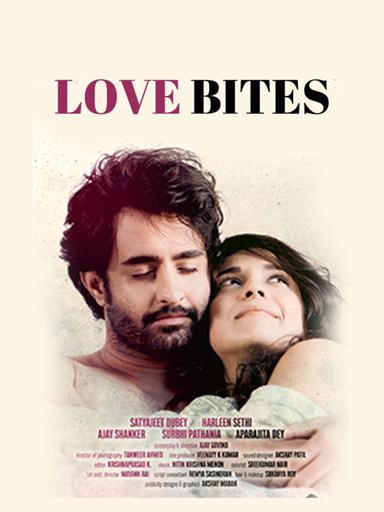How do the typography and color scheme of the poster contribute to its overall impact? The typography of 'Love Bites' uses a modern, somewhat whimsical font that aligns with the film's romantic and youthful theme. The color scheme, consisting of pastel pinks and whites, supports a light, airy feel, evocative of both innocence and passion, crafting an inviting and emotionally resonant visual appeal. 